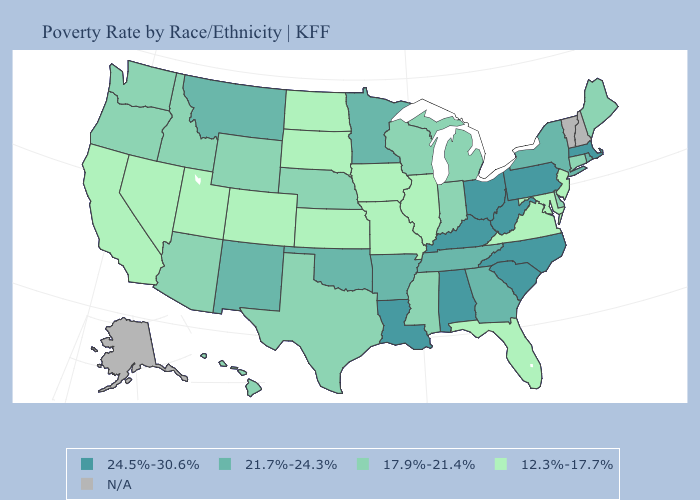Does the map have missing data?
Give a very brief answer. Yes. What is the value of Oklahoma?
Answer briefly. 21.7%-24.3%. What is the lowest value in states that border Utah?
Keep it brief. 12.3%-17.7%. What is the lowest value in states that border South Carolina?
Answer briefly. 21.7%-24.3%. Among the states that border Delaware , which have the highest value?
Give a very brief answer. Pennsylvania. What is the lowest value in the USA?
Write a very short answer. 12.3%-17.7%. How many symbols are there in the legend?
Be succinct. 5. Is the legend a continuous bar?
Keep it brief. No. Among the states that border Nevada , which have the lowest value?
Be succinct. California, Utah. Name the states that have a value in the range N/A?
Quick response, please. Alaska, New Hampshire, Vermont. Does Kansas have the highest value in the MidWest?
Short answer required. No. What is the value of Oklahoma?
Short answer required. 21.7%-24.3%. Among the states that border Washington , which have the highest value?
Concise answer only. Idaho, Oregon. What is the highest value in the MidWest ?
Short answer required. 24.5%-30.6%. 